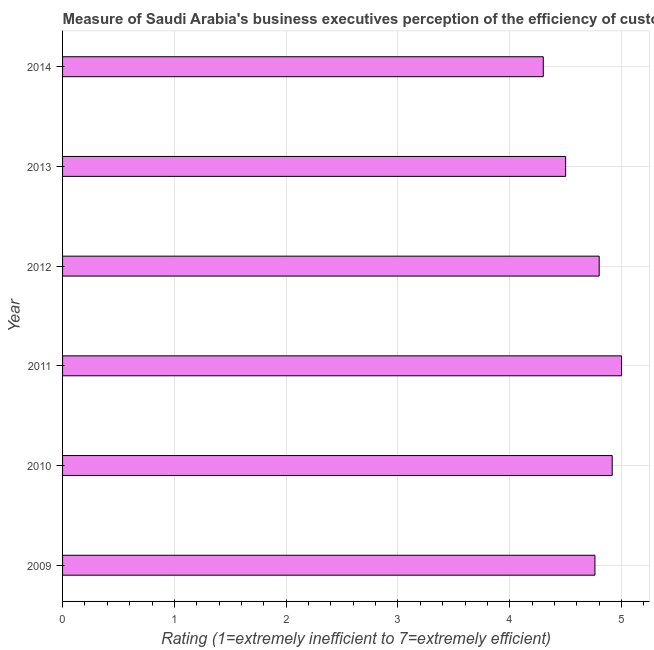Does the graph contain any zero values?
Ensure brevity in your answer.  No. Does the graph contain grids?
Your answer should be compact. Yes. What is the title of the graph?
Keep it short and to the point. Measure of Saudi Arabia's business executives perception of the efficiency of customs procedures. What is the label or title of the X-axis?
Ensure brevity in your answer.  Rating (1=extremely inefficient to 7=extremely efficient). What is the label or title of the Y-axis?
Your answer should be compact. Year. What is the rating measuring burden of customs procedure in 2013?
Ensure brevity in your answer.  4.5. In which year was the rating measuring burden of customs procedure maximum?
Provide a succinct answer. 2011. In which year was the rating measuring burden of customs procedure minimum?
Provide a succinct answer. 2014. What is the sum of the rating measuring burden of customs procedure?
Keep it short and to the point. 28.28. What is the difference between the rating measuring burden of customs procedure in 2009 and 2012?
Ensure brevity in your answer.  -0.04. What is the average rating measuring burden of customs procedure per year?
Your answer should be compact. 4.71. What is the median rating measuring burden of customs procedure?
Your response must be concise. 4.78. In how many years, is the rating measuring burden of customs procedure greater than 3.2 ?
Offer a terse response. 6. Do a majority of the years between 2014 and 2011 (inclusive) have rating measuring burden of customs procedure greater than 0.8 ?
Provide a short and direct response. Yes. What is the ratio of the rating measuring burden of customs procedure in 2011 to that in 2014?
Keep it short and to the point. 1.16. Is the rating measuring burden of customs procedure in 2011 less than that in 2013?
Ensure brevity in your answer.  No. Is the difference between the rating measuring burden of customs procedure in 2009 and 2013 greater than the difference between any two years?
Provide a succinct answer. No. What is the difference between the highest and the second highest rating measuring burden of customs procedure?
Provide a short and direct response. 0.08. What is the difference between the highest and the lowest rating measuring burden of customs procedure?
Provide a short and direct response. 0.7. Are all the bars in the graph horizontal?
Keep it short and to the point. Yes. How many years are there in the graph?
Your answer should be very brief. 6. What is the difference between two consecutive major ticks on the X-axis?
Keep it short and to the point. 1. What is the Rating (1=extremely inefficient to 7=extremely efficient) of 2009?
Give a very brief answer. 4.76. What is the Rating (1=extremely inefficient to 7=extremely efficient) in 2010?
Give a very brief answer. 4.92. What is the Rating (1=extremely inefficient to 7=extremely efficient) in 2012?
Your answer should be compact. 4.8. What is the Rating (1=extremely inefficient to 7=extremely efficient) of 2014?
Provide a short and direct response. 4.3. What is the difference between the Rating (1=extremely inefficient to 7=extremely efficient) in 2009 and 2010?
Offer a terse response. -0.15. What is the difference between the Rating (1=extremely inefficient to 7=extremely efficient) in 2009 and 2011?
Offer a terse response. -0.24. What is the difference between the Rating (1=extremely inefficient to 7=extremely efficient) in 2009 and 2012?
Provide a short and direct response. -0.04. What is the difference between the Rating (1=extremely inefficient to 7=extremely efficient) in 2009 and 2013?
Your response must be concise. 0.26. What is the difference between the Rating (1=extremely inefficient to 7=extremely efficient) in 2009 and 2014?
Make the answer very short. 0.46. What is the difference between the Rating (1=extremely inefficient to 7=extremely efficient) in 2010 and 2011?
Keep it short and to the point. -0.08. What is the difference between the Rating (1=extremely inefficient to 7=extremely efficient) in 2010 and 2012?
Offer a very short reply. 0.12. What is the difference between the Rating (1=extremely inefficient to 7=extremely efficient) in 2010 and 2013?
Ensure brevity in your answer.  0.42. What is the difference between the Rating (1=extremely inefficient to 7=extremely efficient) in 2010 and 2014?
Give a very brief answer. 0.62. What is the difference between the Rating (1=extremely inefficient to 7=extremely efficient) in 2011 and 2013?
Your response must be concise. 0.5. What is the difference between the Rating (1=extremely inefficient to 7=extremely efficient) in 2011 and 2014?
Your answer should be very brief. 0.7. What is the difference between the Rating (1=extremely inefficient to 7=extremely efficient) in 2012 and 2013?
Your answer should be very brief. 0.3. What is the difference between the Rating (1=extremely inefficient to 7=extremely efficient) in 2012 and 2014?
Make the answer very short. 0.5. What is the difference between the Rating (1=extremely inefficient to 7=extremely efficient) in 2013 and 2014?
Your answer should be compact. 0.2. What is the ratio of the Rating (1=extremely inefficient to 7=extremely efficient) in 2009 to that in 2012?
Your answer should be very brief. 0.99. What is the ratio of the Rating (1=extremely inefficient to 7=extremely efficient) in 2009 to that in 2013?
Provide a succinct answer. 1.06. What is the ratio of the Rating (1=extremely inefficient to 7=extremely efficient) in 2009 to that in 2014?
Keep it short and to the point. 1.11. What is the ratio of the Rating (1=extremely inefficient to 7=extremely efficient) in 2010 to that in 2013?
Your answer should be very brief. 1.09. What is the ratio of the Rating (1=extremely inefficient to 7=extremely efficient) in 2010 to that in 2014?
Your answer should be compact. 1.14. What is the ratio of the Rating (1=extremely inefficient to 7=extremely efficient) in 2011 to that in 2012?
Make the answer very short. 1.04. What is the ratio of the Rating (1=extremely inefficient to 7=extremely efficient) in 2011 to that in 2013?
Provide a short and direct response. 1.11. What is the ratio of the Rating (1=extremely inefficient to 7=extremely efficient) in 2011 to that in 2014?
Provide a succinct answer. 1.16. What is the ratio of the Rating (1=extremely inefficient to 7=extremely efficient) in 2012 to that in 2013?
Ensure brevity in your answer.  1.07. What is the ratio of the Rating (1=extremely inefficient to 7=extremely efficient) in 2012 to that in 2014?
Offer a terse response. 1.12. What is the ratio of the Rating (1=extremely inefficient to 7=extremely efficient) in 2013 to that in 2014?
Provide a succinct answer. 1.05. 